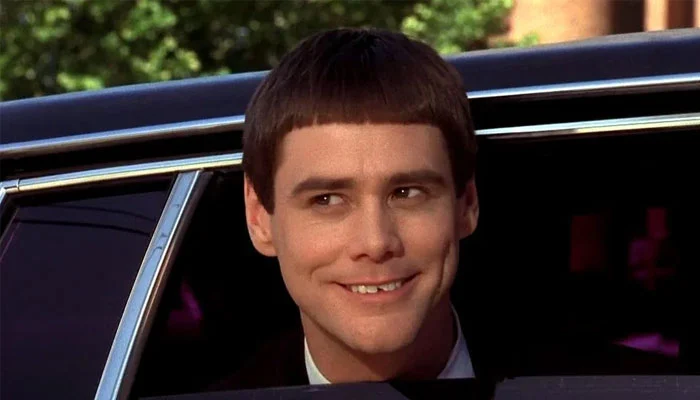Explain the visual content of the image in great detail. In the image, there is a young man with a radiant, joyful smile, showing his teeth. He appears to be sitting in a car, popping his head out of a partially shown window. His straight brown hair is neatly combed, and he wears a dark suit with a slightly visible white shirt underneath. The background offers a glimpse of a blurred, tree-lined street, suggesting the car is in motion. His eyes are bright and seem to gleam with a playful or mischievous charm as they look straight towards the viewer. 